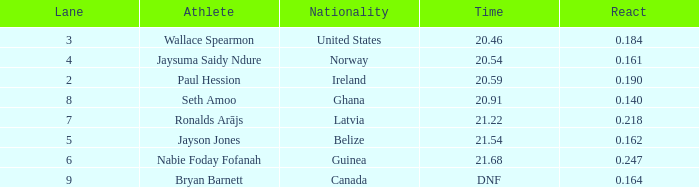Who is the athlete when react is 0.164? Bryan Barnett. 